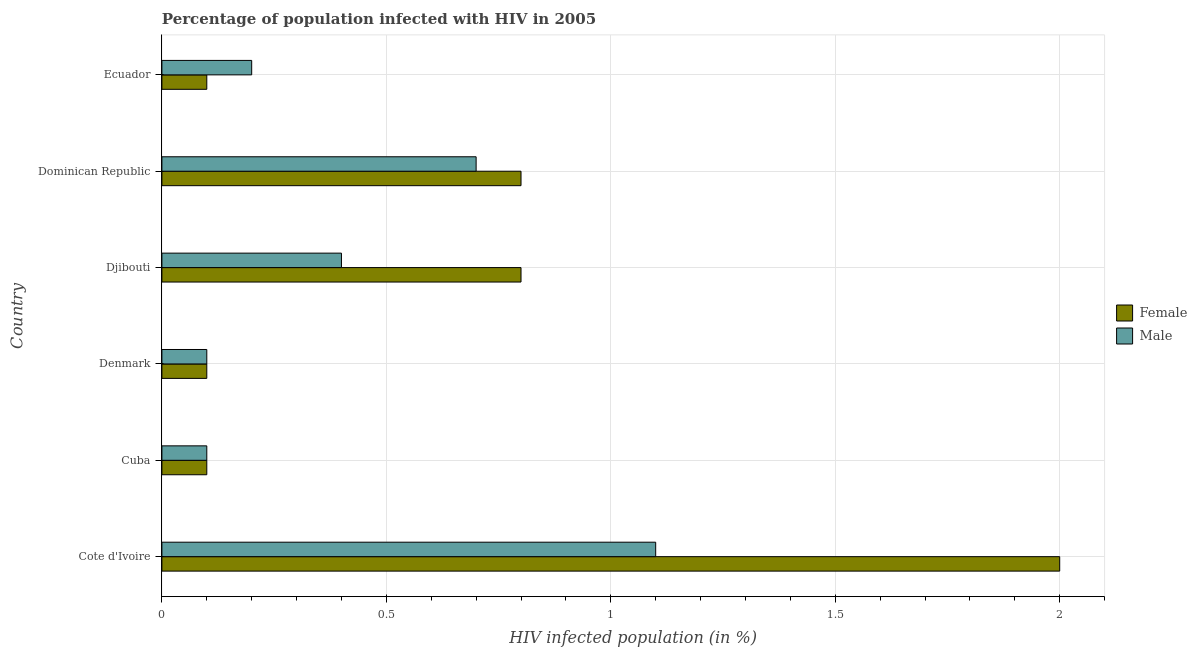How many groups of bars are there?
Offer a very short reply. 6. Are the number of bars on each tick of the Y-axis equal?
Offer a very short reply. Yes. In how many cases, is the number of bars for a given country not equal to the number of legend labels?
Keep it short and to the point. 0. Across all countries, what is the maximum percentage of females who are infected with hiv?
Ensure brevity in your answer.  2. Across all countries, what is the minimum percentage of females who are infected with hiv?
Keep it short and to the point. 0.1. In which country was the percentage of males who are infected with hiv maximum?
Give a very brief answer. Cote d'Ivoire. In which country was the percentage of females who are infected with hiv minimum?
Keep it short and to the point. Cuba. What is the total percentage of males who are infected with hiv in the graph?
Offer a terse response. 2.6. What is the difference between the percentage of females who are infected with hiv in Dominican Republic and that in Ecuador?
Provide a succinct answer. 0.7. What is the average percentage of males who are infected with hiv per country?
Give a very brief answer. 0.43. What is the ratio of the percentage of males who are infected with hiv in Djibouti to that in Dominican Republic?
Your response must be concise. 0.57. Is the percentage of females who are infected with hiv in Cuba less than that in Dominican Republic?
Your answer should be very brief. Yes. In how many countries, is the percentage of males who are infected with hiv greater than the average percentage of males who are infected with hiv taken over all countries?
Your response must be concise. 2. Is the sum of the percentage of females who are infected with hiv in Cote d'Ivoire and Djibouti greater than the maximum percentage of males who are infected with hiv across all countries?
Offer a very short reply. Yes. What does the 2nd bar from the bottom in Ecuador represents?
Give a very brief answer. Male. How many bars are there?
Your response must be concise. 12. How many countries are there in the graph?
Keep it short and to the point. 6. Does the graph contain grids?
Keep it short and to the point. Yes. Where does the legend appear in the graph?
Provide a succinct answer. Center right. How many legend labels are there?
Provide a short and direct response. 2. How are the legend labels stacked?
Your answer should be compact. Vertical. What is the title of the graph?
Offer a very short reply. Percentage of population infected with HIV in 2005. What is the label or title of the X-axis?
Give a very brief answer. HIV infected population (in %). What is the HIV infected population (in %) of Female in Cote d'Ivoire?
Offer a very short reply. 2. What is the HIV infected population (in %) in Female in Cuba?
Offer a terse response. 0.1. What is the HIV infected population (in %) of Female in Denmark?
Provide a short and direct response. 0.1. What is the HIV infected population (in %) of Male in Djibouti?
Your answer should be very brief. 0.4. What is the HIV infected population (in %) of Female in Ecuador?
Make the answer very short. 0.1. What is the HIV infected population (in %) of Male in Ecuador?
Your answer should be compact. 0.2. Across all countries, what is the maximum HIV infected population (in %) of Female?
Your answer should be compact. 2. Across all countries, what is the maximum HIV infected population (in %) of Male?
Offer a terse response. 1.1. Across all countries, what is the minimum HIV infected population (in %) in Male?
Offer a terse response. 0.1. What is the difference between the HIV infected population (in %) of Female in Cote d'Ivoire and that in Cuba?
Your response must be concise. 1.9. What is the difference between the HIV infected population (in %) of Male in Cote d'Ivoire and that in Cuba?
Offer a terse response. 1. What is the difference between the HIV infected population (in %) of Female in Cote d'Ivoire and that in Denmark?
Offer a terse response. 1.9. What is the difference between the HIV infected population (in %) of Male in Cote d'Ivoire and that in Dominican Republic?
Provide a succinct answer. 0.4. What is the difference between the HIV infected population (in %) of Male in Cote d'Ivoire and that in Ecuador?
Your answer should be very brief. 0.9. What is the difference between the HIV infected population (in %) in Female in Cuba and that in Denmark?
Offer a terse response. 0. What is the difference between the HIV infected population (in %) in Male in Cuba and that in Denmark?
Offer a very short reply. 0. What is the difference between the HIV infected population (in %) of Female in Cuba and that in Djibouti?
Provide a short and direct response. -0.7. What is the difference between the HIV infected population (in %) in Male in Cuba and that in Djibouti?
Make the answer very short. -0.3. What is the difference between the HIV infected population (in %) of Female in Cuba and that in Dominican Republic?
Provide a short and direct response. -0.7. What is the difference between the HIV infected population (in %) of Male in Cuba and that in Dominican Republic?
Give a very brief answer. -0.6. What is the difference between the HIV infected population (in %) in Female in Denmark and that in Djibouti?
Provide a succinct answer. -0.7. What is the difference between the HIV infected population (in %) of Female in Denmark and that in Dominican Republic?
Your response must be concise. -0.7. What is the difference between the HIV infected population (in %) in Female in Denmark and that in Ecuador?
Provide a succinct answer. 0. What is the difference between the HIV infected population (in %) in Male in Djibouti and that in Dominican Republic?
Keep it short and to the point. -0.3. What is the difference between the HIV infected population (in %) in Female in Djibouti and that in Ecuador?
Keep it short and to the point. 0.7. What is the difference between the HIV infected population (in %) of Female in Dominican Republic and that in Ecuador?
Offer a terse response. 0.7. What is the difference between the HIV infected population (in %) of Female in Cote d'Ivoire and the HIV infected population (in %) of Male in Cuba?
Provide a short and direct response. 1.9. What is the difference between the HIV infected population (in %) in Female in Cote d'Ivoire and the HIV infected population (in %) in Male in Denmark?
Offer a very short reply. 1.9. What is the difference between the HIV infected population (in %) in Female in Cote d'Ivoire and the HIV infected population (in %) in Male in Djibouti?
Your answer should be compact. 1.6. What is the difference between the HIV infected population (in %) in Female in Cote d'Ivoire and the HIV infected population (in %) in Male in Ecuador?
Your answer should be very brief. 1.8. What is the difference between the HIV infected population (in %) in Female in Cuba and the HIV infected population (in %) in Male in Denmark?
Offer a terse response. 0. What is the difference between the HIV infected population (in %) of Female in Denmark and the HIV infected population (in %) of Male in Djibouti?
Ensure brevity in your answer.  -0.3. What is the difference between the HIV infected population (in %) in Female in Djibouti and the HIV infected population (in %) in Male in Dominican Republic?
Your answer should be compact. 0.1. What is the difference between the HIV infected population (in %) of Female in Djibouti and the HIV infected population (in %) of Male in Ecuador?
Provide a short and direct response. 0.6. What is the difference between the HIV infected population (in %) in Female in Dominican Republic and the HIV infected population (in %) in Male in Ecuador?
Your response must be concise. 0.6. What is the average HIV infected population (in %) in Female per country?
Offer a very short reply. 0.65. What is the average HIV infected population (in %) in Male per country?
Your answer should be compact. 0.43. What is the difference between the HIV infected population (in %) in Female and HIV infected population (in %) in Male in Denmark?
Provide a succinct answer. 0. What is the difference between the HIV infected population (in %) of Female and HIV infected population (in %) of Male in Djibouti?
Provide a short and direct response. 0.4. What is the difference between the HIV infected population (in %) in Female and HIV infected population (in %) in Male in Dominican Republic?
Keep it short and to the point. 0.1. What is the ratio of the HIV infected population (in %) in Female in Cote d'Ivoire to that in Cuba?
Your response must be concise. 20. What is the ratio of the HIV infected population (in %) of Male in Cote d'Ivoire to that in Cuba?
Make the answer very short. 11. What is the ratio of the HIV infected population (in %) in Female in Cote d'Ivoire to that in Denmark?
Offer a terse response. 20. What is the ratio of the HIV infected population (in %) in Female in Cote d'Ivoire to that in Djibouti?
Provide a short and direct response. 2.5. What is the ratio of the HIV infected population (in %) in Male in Cote d'Ivoire to that in Djibouti?
Give a very brief answer. 2.75. What is the ratio of the HIV infected population (in %) in Male in Cote d'Ivoire to that in Dominican Republic?
Your answer should be very brief. 1.57. What is the ratio of the HIV infected population (in %) in Male in Cote d'Ivoire to that in Ecuador?
Keep it short and to the point. 5.5. What is the ratio of the HIV infected population (in %) of Male in Cuba to that in Denmark?
Offer a very short reply. 1. What is the ratio of the HIV infected population (in %) of Male in Cuba to that in Djibouti?
Provide a short and direct response. 0.25. What is the ratio of the HIV infected population (in %) in Female in Cuba to that in Dominican Republic?
Provide a short and direct response. 0.12. What is the ratio of the HIV infected population (in %) in Male in Cuba to that in Dominican Republic?
Provide a short and direct response. 0.14. What is the ratio of the HIV infected population (in %) of Female in Cuba to that in Ecuador?
Ensure brevity in your answer.  1. What is the ratio of the HIV infected population (in %) in Female in Denmark to that in Dominican Republic?
Your response must be concise. 0.12. What is the ratio of the HIV infected population (in %) of Male in Denmark to that in Dominican Republic?
Offer a terse response. 0.14. What is the ratio of the HIV infected population (in %) of Male in Denmark to that in Ecuador?
Your answer should be very brief. 0.5. What is the ratio of the HIV infected population (in %) in Male in Djibouti to that in Dominican Republic?
Your response must be concise. 0.57. What is the ratio of the HIV infected population (in %) of Female in Djibouti to that in Ecuador?
Your response must be concise. 8. What is the difference between the highest and the lowest HIV infected population (in %) of Male?
Your answer should be very brief. 1. 